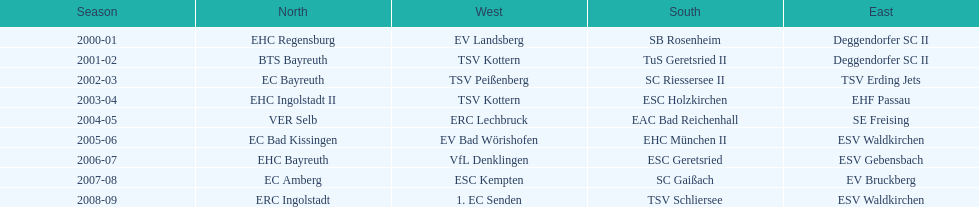What was the first club for the north in the 2000's? EHC Regensburg. 